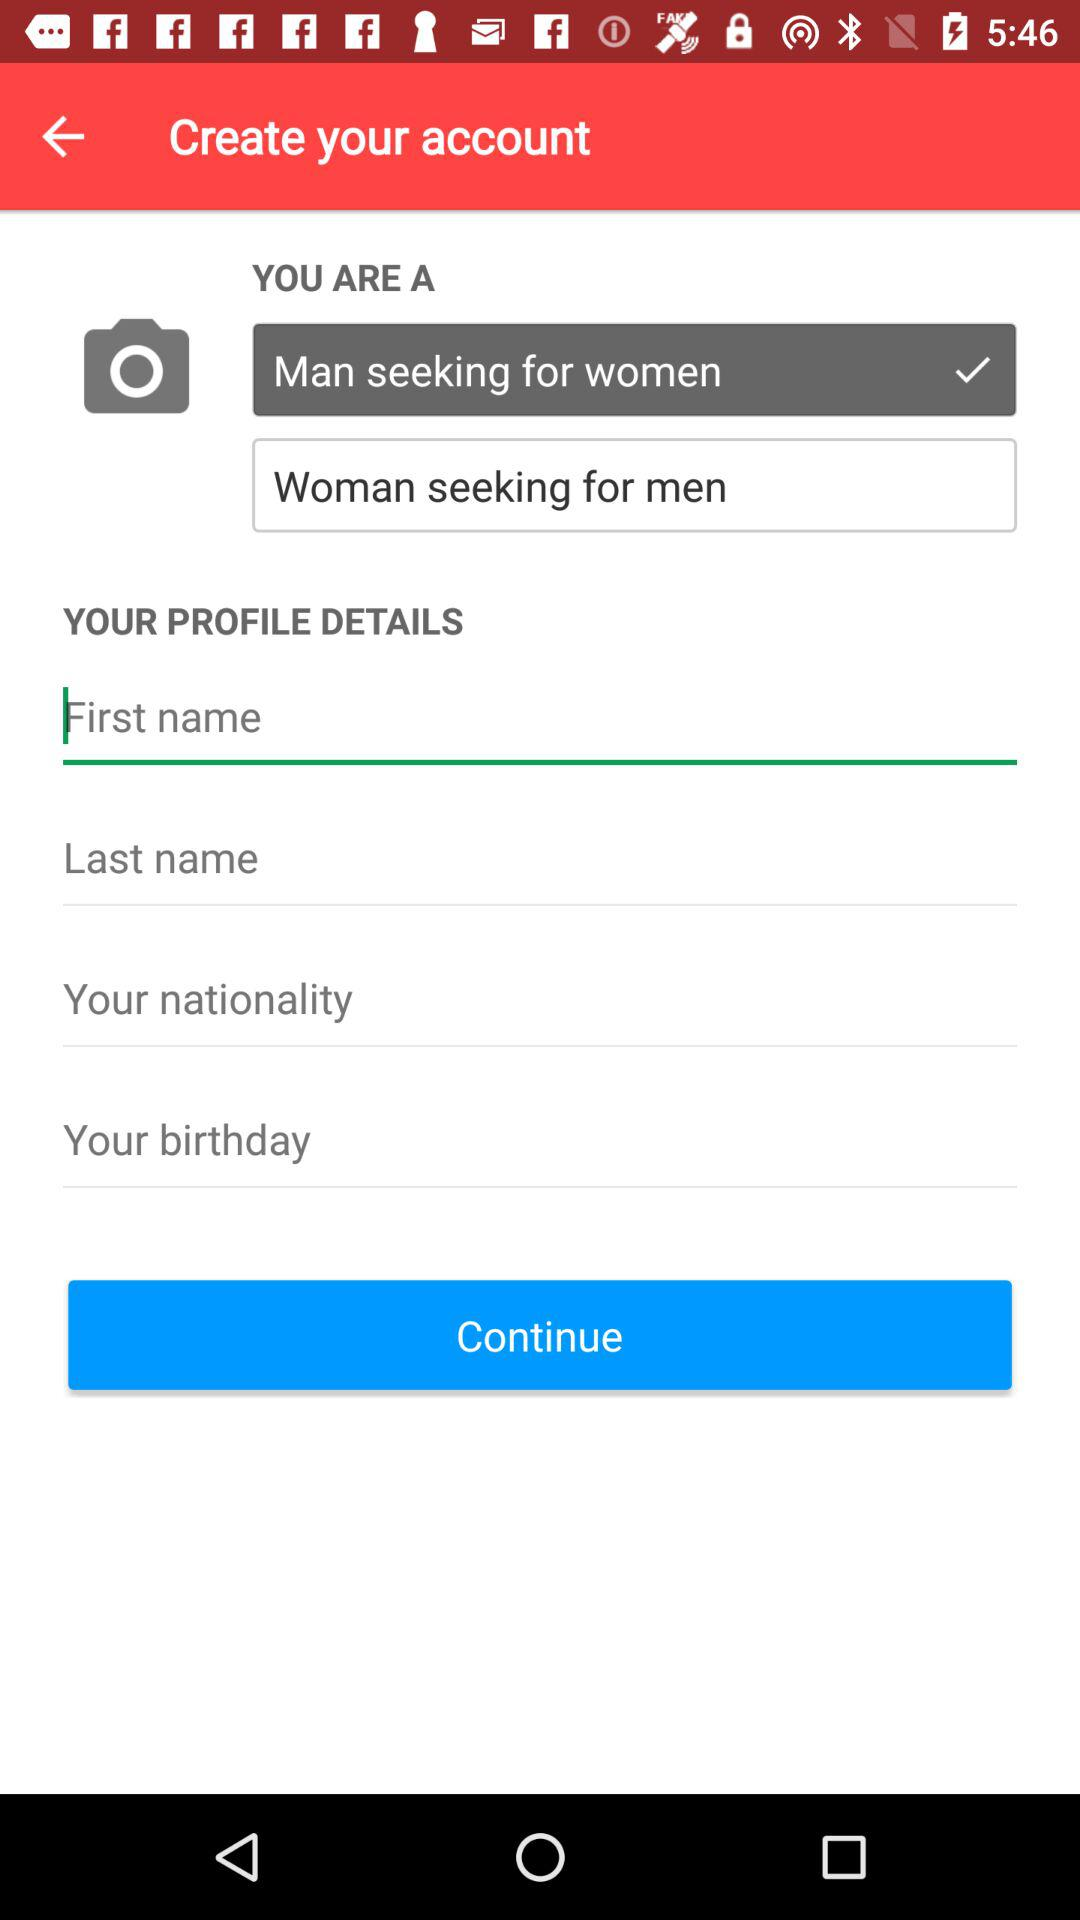How many sex options are available?
Answer the question using a single word or phrase. 2 